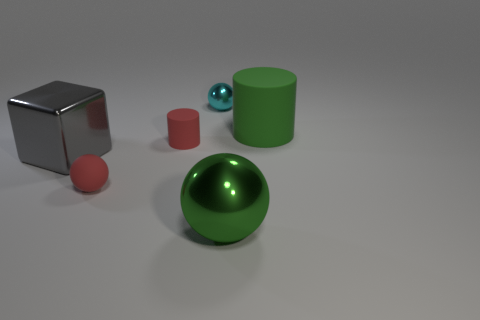Subtract 1 spheres. How many spheres are left? 2 Subtract all cyan metallic balls. How many balls are left? 2 Add 3 big green spheres. How many objects exist? 9 Subtract all cylinders. How many objects are left? 4 Add 5 shiny objects. How many shiny objects are left? 8 Add 5 large shiny objects. How many large shiny objects exist? 7 Subtract 0 red blocks. How many objects are left? 6 Subtract all red objects. Subtract all metallic balls. How many objects are left? 2 